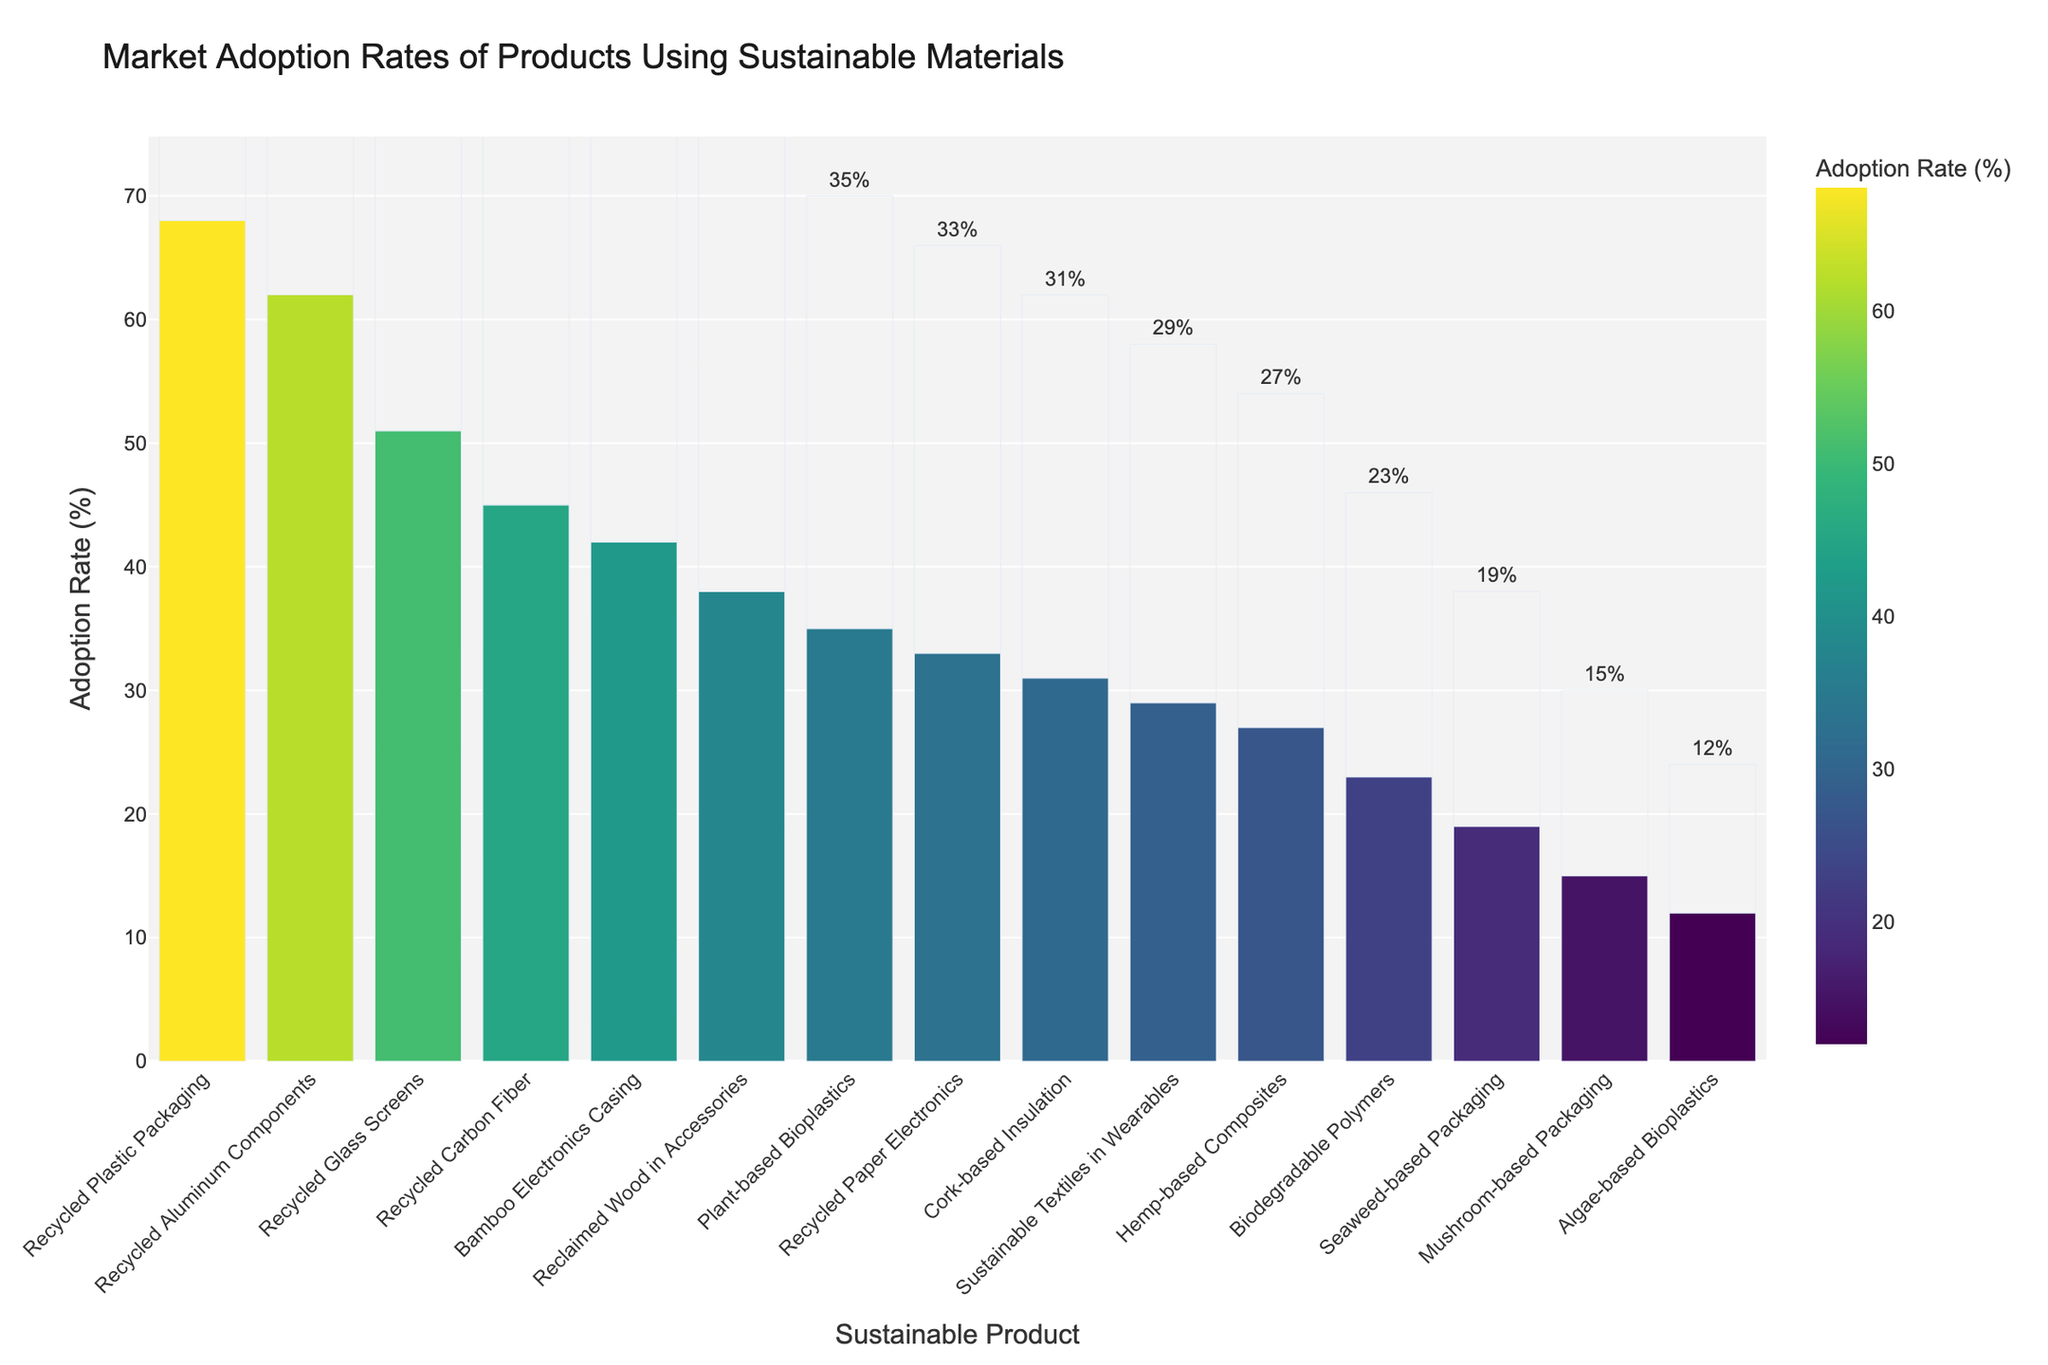Which product has the highest market adoption rate? The bar representing "Recycled Plastic Packaging" is the tallest, indicating it has the highest adoption rate among the listed products.
Answer: Recycled Plastic Packaging How does the adoption rate of Recycled Plastic Packaging compare to Recycled Aluminum Components? The adoption rate for Recycled Plastic Packaging is 68%, while that for Recycled Aluminum Components is 62%. By comparing the two values, Recycled Plastic Packaging has a higher adoption rate.
Answer: Recycled Plastic Packaging has a higher adoption rate What is the average adoption rate of Bamboo Electronics Casing and Sustainable Textiles in Wearables? The adoption rate for Bamboo Electronics Casing is 42% and for Sustainable Textiles in Wearables is 29%. Adding these together gives 42 + 29 = 71. Dividing by 2 gives the average: 71 / 2 = 35.5%.
Answer: 35.5% Which product has a lower adoption rate: Mushroom-based Packaging or Recycled Paper Electronics? Mushroom-based Packaging has an adoption rate of 15%, while Recycled Paper Electronics has an adoption rate of 33%. Comparing the two, Mushroom-based Packaging has a lower adoption rate.
Answer: Mushroom-based Packaging What is the total adoption rate of all products whose adoption rate is below 25%? The products below 25% are Biodegradable Polymers (23%), Mushroom-based Packaging (15%), Seaweed-based Packaging (19%), and Algae-based Bioplastics (12%). Summing these gives 23 + 15 + 19 + 12 = 69%.
Answer: 69% What is the range of adoption rates for the products shown? The highest adoption rate is for Recycled Plastic Packaging at 68%, and the lowest is for Algae-based Bioplastics at 12%. The range is calculated as 68 - 12 = 56%.
Answer: 56% Which products have adoption rates that are close to 30%? The bars for Reclaimed Wood in Accessories (38%), Cork-based Insulation (31%), and Recycled Paper Electronics (33%) are visually close to the 30% mark.
Answer: Cork-based Insulation and Recycled Paper Electronics How many products have an adoption rate higher than 50%? Visually inspecting the bars, there are three products with adoption rates higher than 50%: Recycled Plastic Packaging (68%), Recycled Aluminum Components (62%), and Recycled Glass Screens (51%).
Answer: 3 